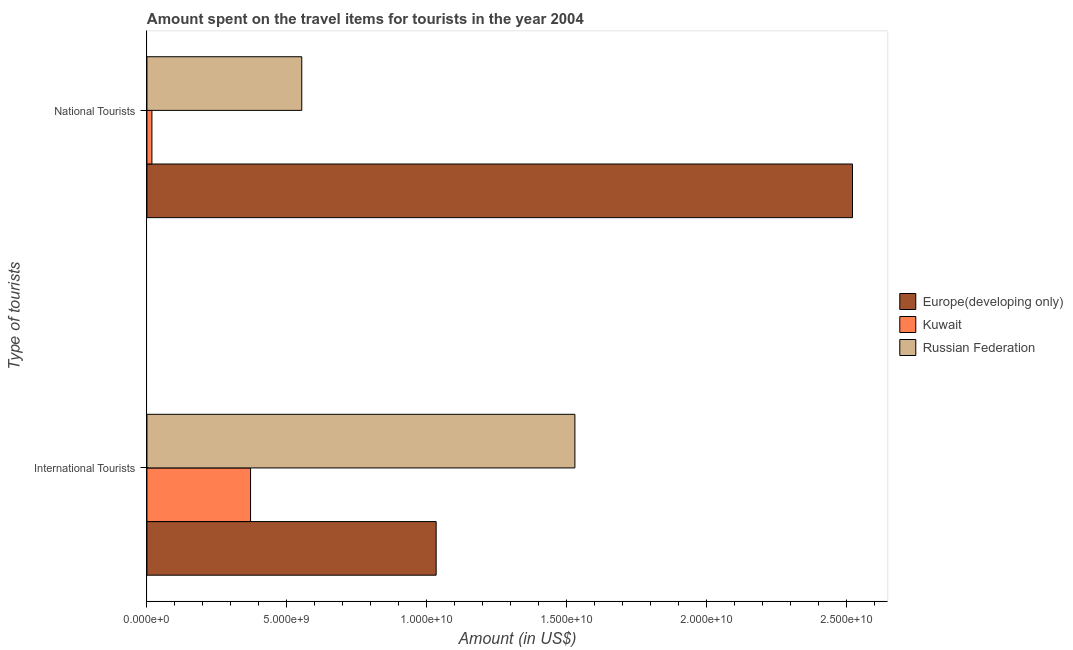How many different coloured bars are there?
Give a very brief answer. 3. How many bars are there on the 2nd tick from the top?
Offer a very short reply. 3. How many bars are there on the 1st tick from the bottom?
Offer a terse response. 3. What is the label of the 2nd group of bars from the top?
Ensure brevity in your answer.  International Tourists. What is the amount spent on travel items of national tourists in Kuwait?
Your response must be concise. 1.78e+08. Across all countries, what is the maximum amount spent on travel items of national tourists?
Offer a very short reply. 2.52e+1. Across all countries, what is the minimum amount spent on travel items of national tourists?
Your answer should be compact. 1.78e+08. In which country was the amount spent on travel items of international tourists maximum?
Offer a terse response. Russian Federation. In which country was the amount spent on travel items of international tourists minimum?
Give a very brief answer. Kuwait. What is the total amount spent on travel items of national tourists in the graph?
Provide a short and direct response. 3.09e+1. What is the difference between the amount spent on travel items of national tourists in Europe(developing only) and that in Kuwait?
Your answer should be very brief. 2.50e+1. What is the difference between the amount spent on travel items of national tourists in Europe(developing only) and the amount spent on travel items of international tourists in Kuwait?
Offer a very short reply. 2.15e+1. What is the average amount spent on travel items of national tourists per country?
Give a very brief answer. 1.03e+1. What is the difference between the amount spent on travel items of international tourists and amount spent on travel items of national tourists in Russian Federation?
Provide a succinct answer. 9.76e+09. What is the ratio of the amount spent on travel items of international tourists in Europe(developing only) to that in Kuwait?
Provide a succinct answer. 2.79. In how many countries, is the amount spent on travel items of national tourists greater than the average amount spent on travel items of national tourists taken over all countries?
Your response must be concise. 1. What does the 1st bar from the top in International Tourists represents?
Your answer should be very brief. Russian Federation. What does the 3rd bar from the bottom in National Tourists represents?
Provide a succinct answer. Russian Federation. How many countries are there in the graph?
Offer a terse response. 3. What is the difference between two consecutive major ticks on the X-axis?
Offer a terse response. 5.00e+09. What is the title of the graph?
Give a very brief answer. Amount spent on the travel items for tourists in the year 2004. What is the label or title of the Y-axis?
Keep it short and to the point. Type of tourists. What is the Amount (in US$) in Europe(developing only) in International Tourists?
Your answer should be very brief. 1.03e+1. What is the Amount (in US$) of Kuwait in International Tourists?
Offer a very short reply. 3.70e+09. What is the Amount (in US$) of Russian Federation in International Tourists?
Ensure brevity in your answer.  1.53e+1. What is the Amount (in US$) of Europe(developing only) in National Tourists?
Keep it short and to the point. 2.52e+1. What is the Amount (in US$) in Kuwait in National Tourists?
Provide a short and direct response. 1.78e+08. What is the Amount (in US$) of Russian Federation in National Tourists?
Make the answer very short. 5.53e+09. Across all Type of tourists, what is the maximum Amount (in US$) of Europe(developing only)?
Your answer should be compact. 2.52e+1. Across all Type of tourists, what is the maximum Amount (in US$) in Kuwait?
Your answer should be very brief. 3.70e+09. Across all Type of tourists, what is the maximum Amount (in US$) of Russian Federation?
Your answer should be compact. 1.53e+1. Across all Type of tourists, what is the minimum Amount (in US$) of Europe(developing only)?
Make the answer very short. 1.03e+1. Across all Type of tourists, what is the minimum Amount (in US$) in Kuwait?
Give a very brief answer. 1.78e+08. Across all Type of tourists, what is the minimum Amount (in US$) of Russian Federation?
Keep it short and to the point. 5.53e+09. What is the total Amount (in US$) in Europe(developing only) in the graph?
Ensure brevity in your answer.  3.55e+1. What is the total Amount (in US$) of Kuwait in the graph?
Make the answer very short. 3.88e+09. What is the total Amount (in US$) in Russian Federation in the graph?
Ensure brevity in your answer.  2.08e+1. What is the difference between the Amount (in US$) of Europe(developing only) in International Tourists and that in National Tourists?
Provide a succinct answer. -1.49e+1. What is the difference between the Amount (in US$) in Kuwait in International Tourists and that in National Tourists?
Your response must be concise. 3.52e+09. What is the difference between the Amount (in US$) of Russian Federation in International Tourists and that in National Tourists?
Your answer should be compact. 9.76e+09. What is the difference between the Amount (in US$) of Europe(developing only) in International Tourists and the Amount (in US$) of Kuwait in National Tourists?
Your response must be concise. 1.02e+1. What is the difference between the Amount (in US$) in Europe(developing only) in International Tourists and the Amount (in US$) in Russian Federation in National Tourists?
Give a very brief answer. 4.80e+09. What is the difference between the Amount (in US$) of Kuwait in International Tourists and the Amount (in US$) of Russian Federation in National Tourists?
Your response must be concise. -1.83e+09. What is the average Amount (in US$) of Europe(developing only) per Type of tourists?
Offer a very short reply. 1.78e+1. What is the average Amount (in US$) of Kuwait per Type of tourists?
Provide a succinct answer. 1.94e+09. What is the average Amount (in US$) of Russian Federation per Type of tourists?
Your answer should be compact. 1.04e+1. What is the difference between the Amount (in US$) of Europe(developing only) and Amount (in US$) of Kuwait in International Tourists?
Make the answer very short. 6.63e+09. What is the difference between the Amount (in US$) in Europe(developing only) and Amount (in US$) in Russian Federation in International Tourists?
Provide a short and direct response. -4.96e+09. What is the difference between the Amount (in US$) in Kuwait and Amount (in US$) in Russian Federation in International Tourists?
Offer a very short reply. -1.16e+1. What is the difference between the Amount (in US$) in Europe(developing only) and Amount (in US$) in Kuwait in National Tourists?
Ensure brevity in your answer.  2.50e+1. What is the difference between the Amount (in US$) of Europe(developing only) and Amount (in US$) of Russian Federation in National Tourists?
Ensure brevity in your answer.  1.97e+1. What is the difference between the Amount (in US$) of Kuwait and Amount (in US$) of Russian Federation in National Tourists?
Keep it short and to the point. -5.35e+09. What is the ratio of the Amount (in US$) in Europe(developing only) in International Tourists to that in National Tourists?
Your response must be concise. 0.41. What is the ratio of the Amount (in US$) of Kuwait in International Tourists to that in National Tourists?
Make the answer very short. 20.79. What is the ratio of the Amount (in US$) in Russian Federation in International Tourists to that in National Tourists?
Your response must be concise. 2.76. What is the difference between the highest and the second highest Amount (in US$) of Europe(developing only)?
Provide a short and direct response. 1.49e+1. What is the difference between the highest and the second highest Amount (in US$) in Kuwait?
Provide a succinct answer. 3.52e+09. What is the difference between the highest and the second highest Amount (in US$) in Russian Federation?
Your response must be concise. 9.76e+09. What is the difference between the highest and the lowest Amount (in US$) of Europe(developing only)?
Your answer should be very brief. 1.49e+1. What is the difference between the highest and the lowest Amount (in US$) in Kuwait?
Your response must be concise. 3.52e+09. What is the difference between the highest and the lowest Amount (in US$) in Russian Federation?
Provide a succinct answer. 9.76e+09. 